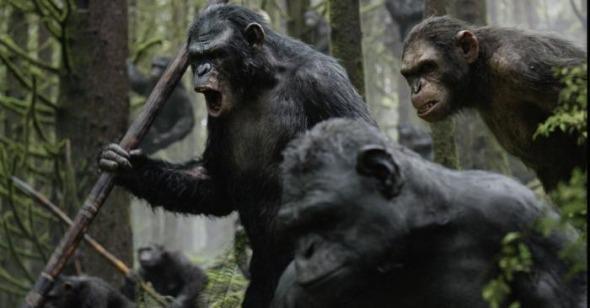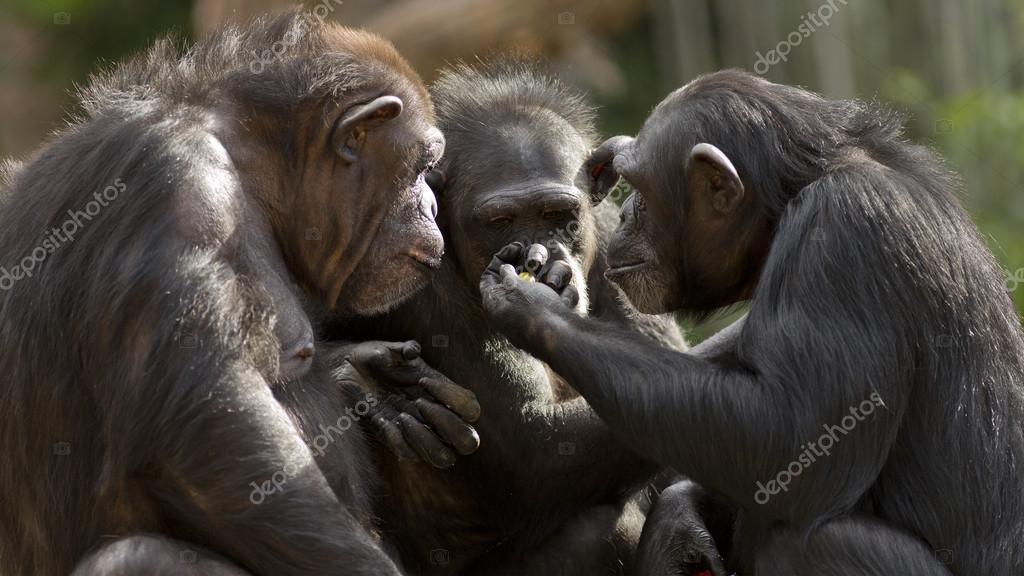The first image is the image on the left, the second image is the image on the right. Examine the images to the left and right. Is the description "The lefthand image includes an adult chimp and a small juvenile chimp." accurate? Answer yes or no. No. The first image is the image on the left, the second image is the image on the right. Given the left and right images, does the statement "There is a chimpanzee showing something in his hand to two other chimpanzees in the right image." hold true? Answer yes or no. Yes. 